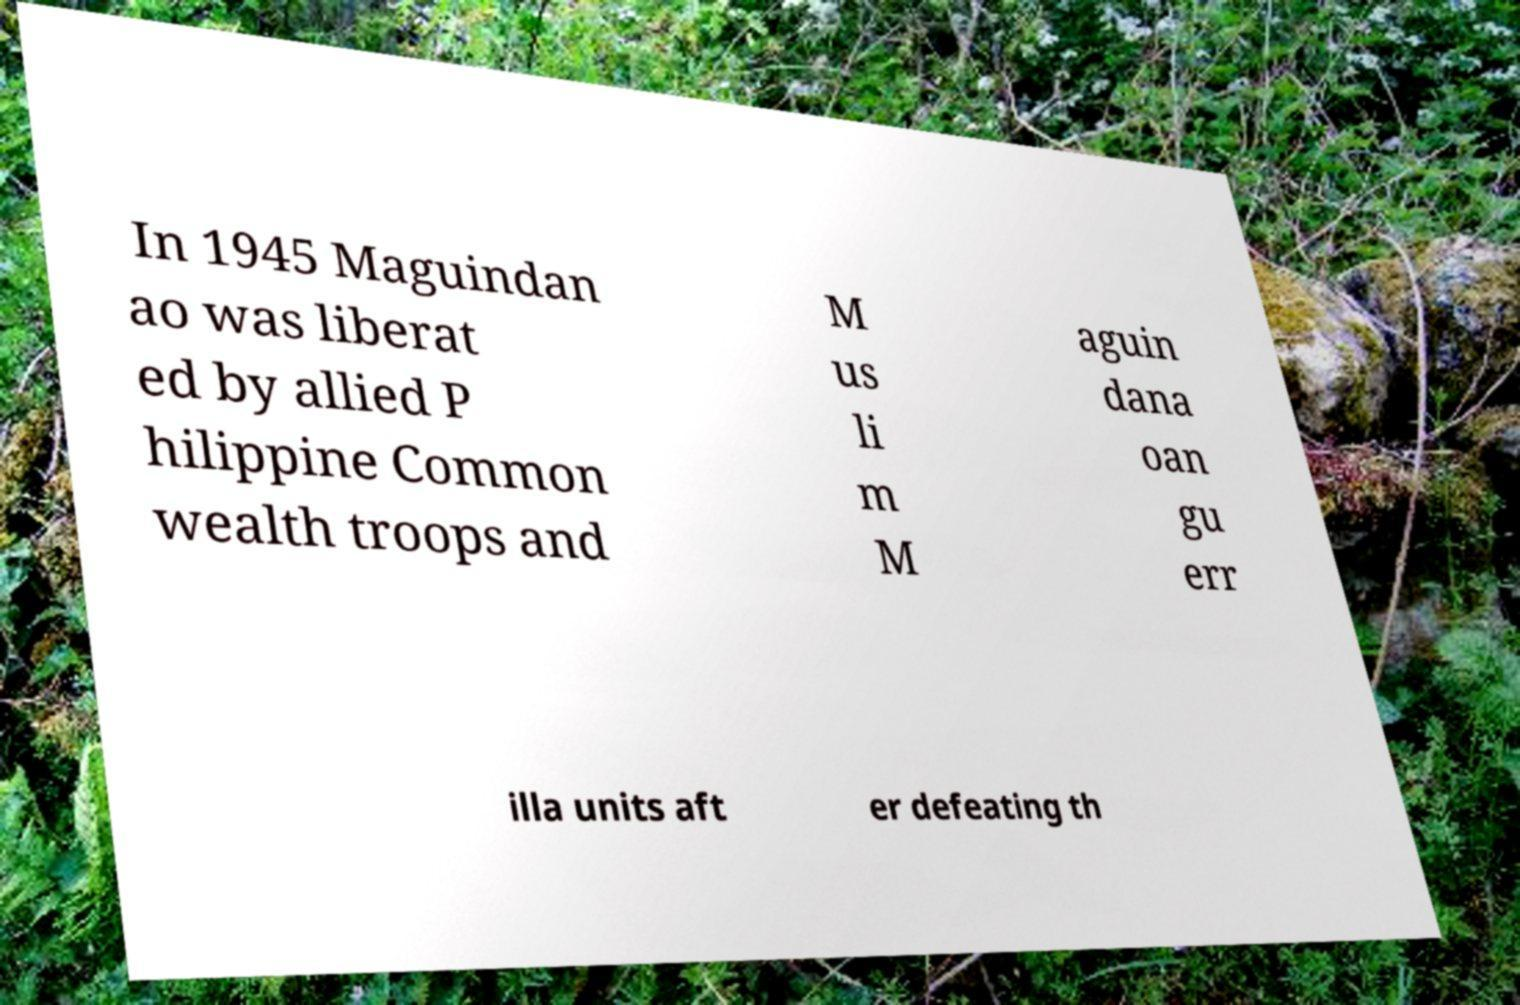Could you assist in decoding the text presented in this image and type it out clearly? In 1945 Maguindan ao was liberat ed by allied P hilippine Common wealth troops and M us li m M aguin dana oan gu err illa units aft er defeating th 